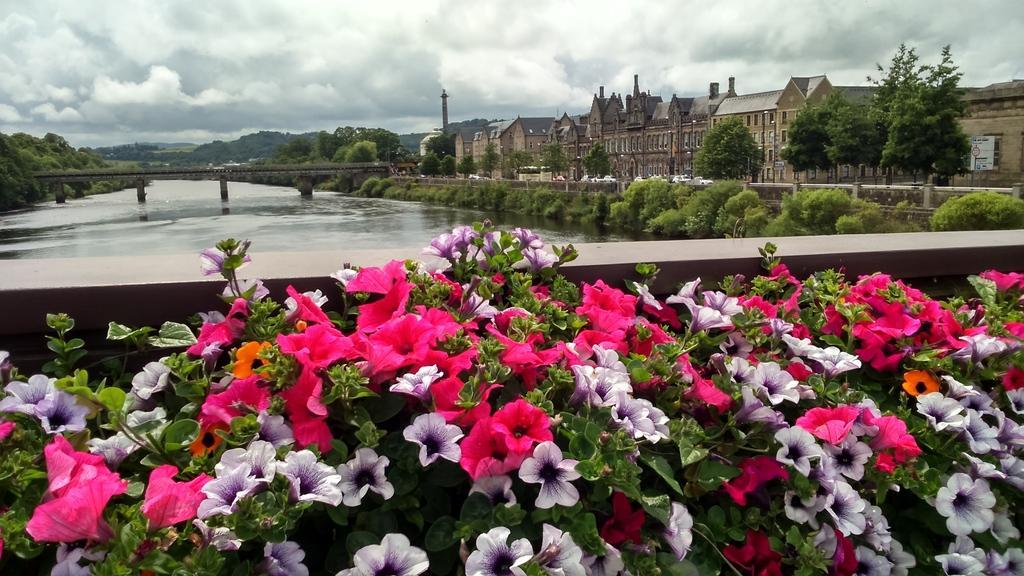How would you summarize this image in a sentence or two? In this image at the bottom there are some flowers and plants, and in the center there is a river, bridge and some trees. And on the right side of the image there are buildings and trees, in the background there are mountains and trees. At the top the sky is cloudy. 